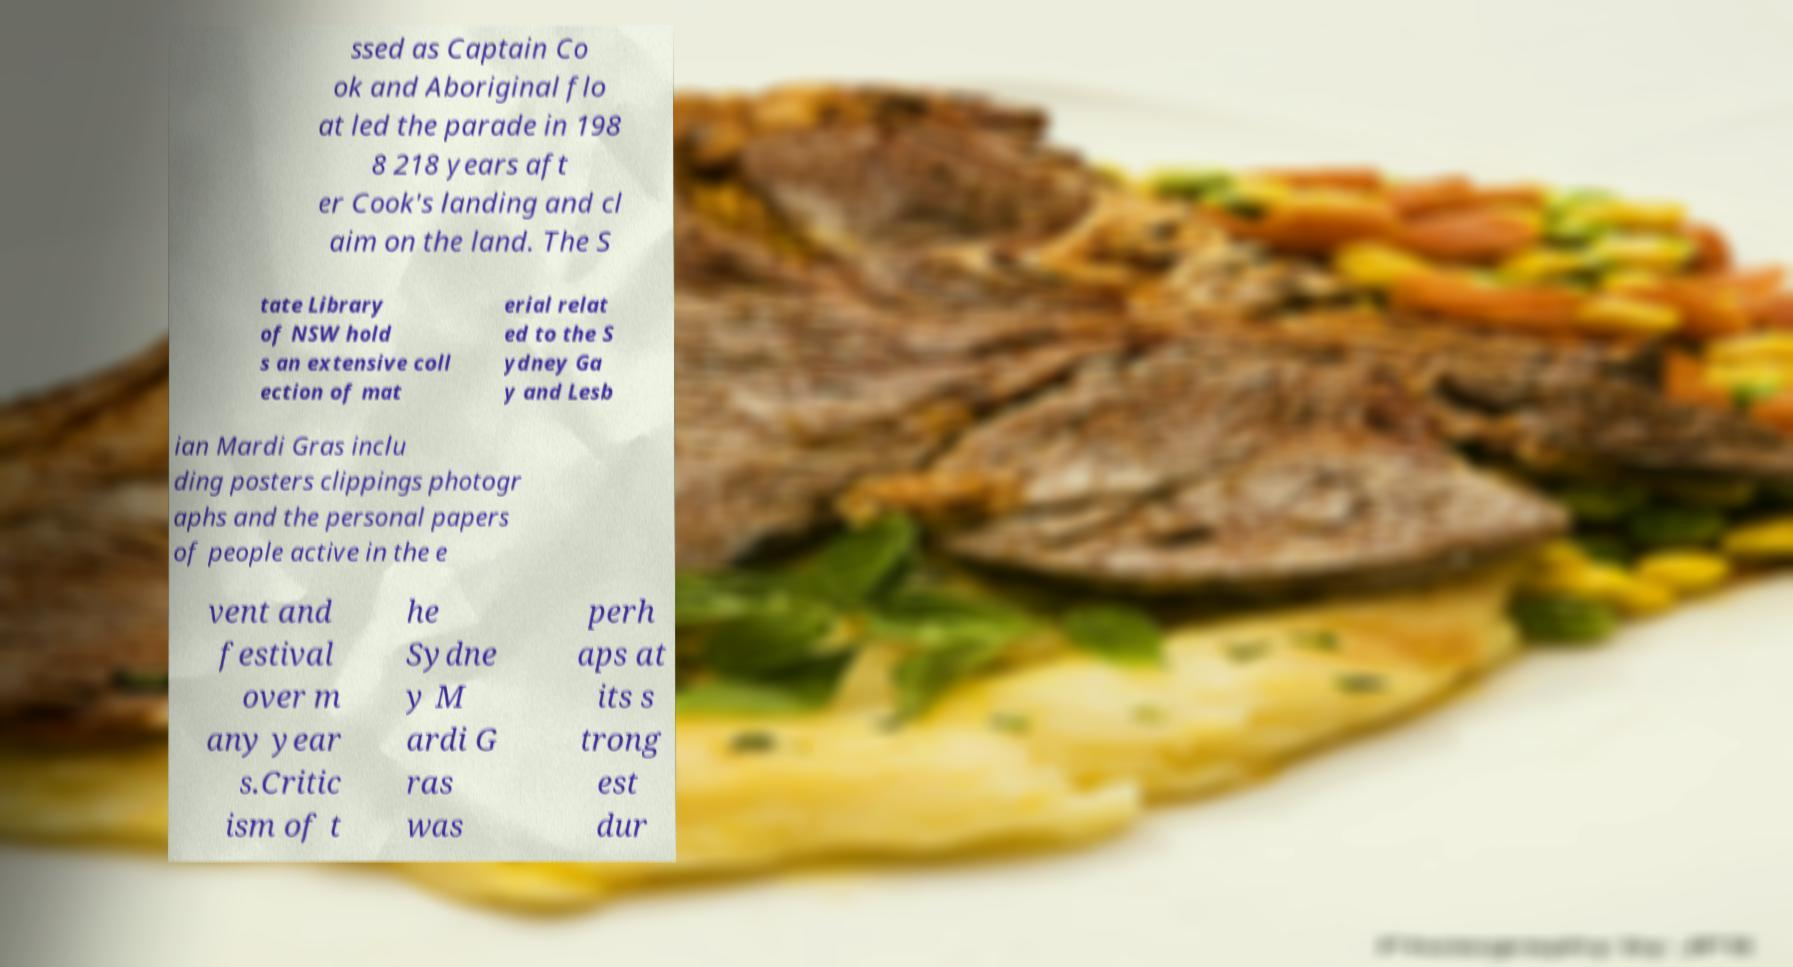What messages or text are displayed in this image? I need them in a readable, typed format. ssed as Captain Co ok and Aboriginal flo at led the parade in 198 8 218 years aft er Cook's landing and cl aim on the land. The S tate Library of NSW hold s an extensive coll ection of mat erial relat ed to the S ydney Ga y and Lesb ian Mardi Gras inclu ding posters clippings photogr aphs and the personal papers of people active in the e vent and festival over m any year s.Critic ism of t he Sydne y M ardi G ras was perh aps at its s trong est dur 